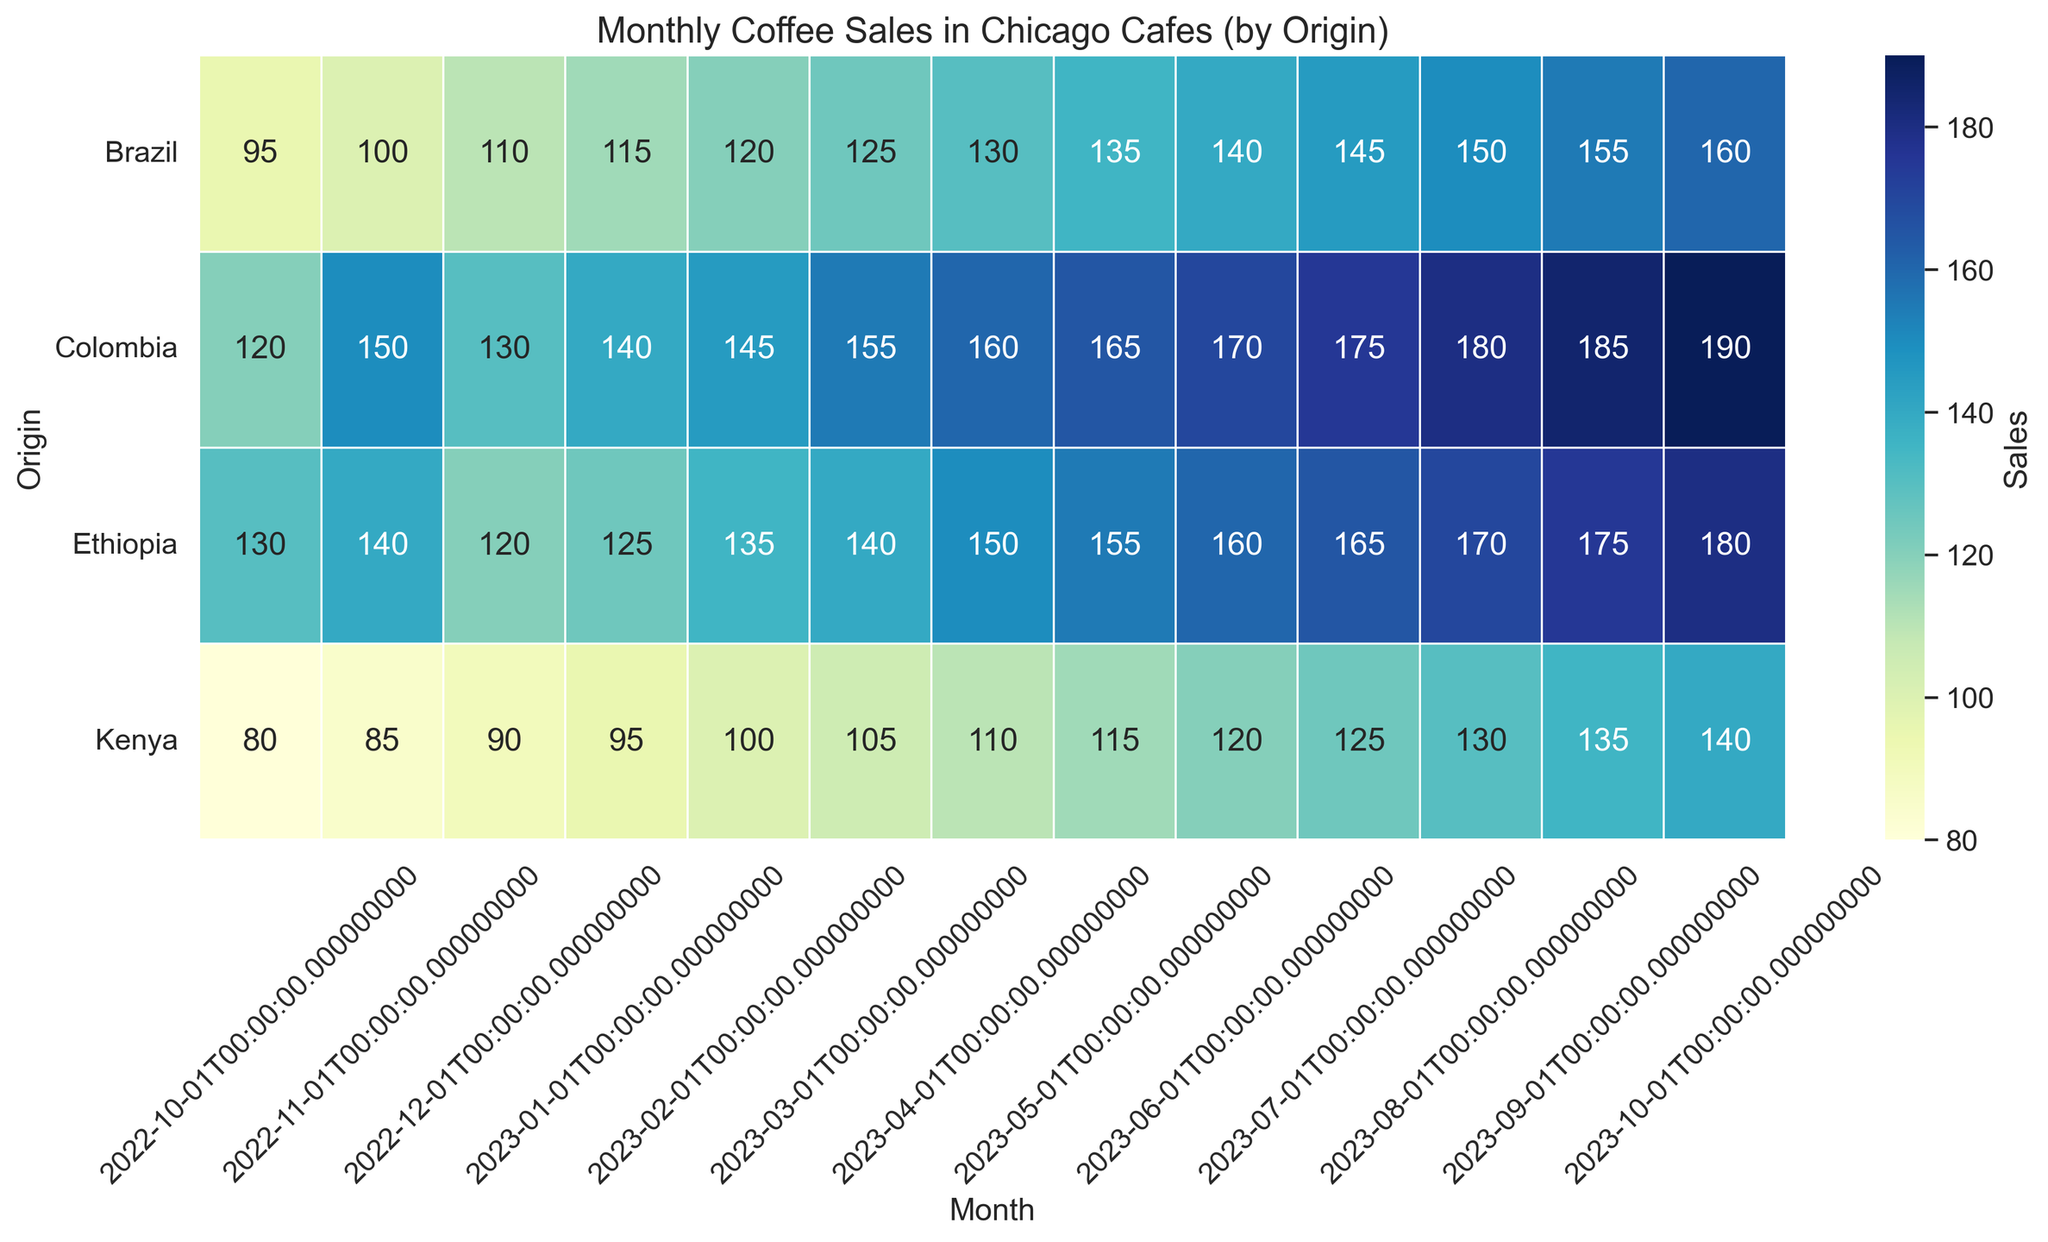Which month had the highest sales for Ethiopian coffee beans? To find this, observe the row corresponding to Ethiopia and identify the cell with the highest number.
Answer: October 2023 How did the sales of Kenyan coffee beans change from October 2022 to October 2023? Compare the October 2022 and October 2023 sales values for Kenyan coffee beans. Calculate the difference: 140 (2023) - 80 (2022) = 60.
Answer: Increased by 60 Which origin had the highest sales in December 2022? Look at the December 2022 column and identify the highest value among the origins.
Answer: Colombia What's the average monthly sales of Brazilian coffee beans from November 2022 to February 2023? Extract the sales figures for Brazil from November 2022 to February 2023, sum them up, and then divide by the number of months (4): (100 + 110 + 115 + 120)/4 = 111.25.
Answer: 111.25 Were Ethiopian coffee beans sales higher in March 2023 or in June 2023? Compare the sales figures for Ethiopia in March 2023 and June 2023: 140 (March) vs 160 (June).
Answer: June 2023 Compare the trend of sales for Colombian and Kenyan coffee beans from January 2023 to July 2023. Which origin had a steeper increase? Calculate the increase for both origins over the period: 
Colombian sales in July 2023 - January 2023 = 175 - 140 = 35. 
Kenyan sales in July 2023 - January 2023 = 125 - 95 = 30.
Answer: Colombia What is the total sales for all origins combined in April 2023? Sum the sales values for all origins in April 2023: 160 (Colombia) + 130 (Brazil) + 150 (Ethiopia) + 110 (Kenya) = 550.
Answer: 550 Which month/coffee origin combination had the lowest sales? Identify the cell with the lowest value in the heatmap.
Answer: Kenya in October 2022 Did the Brazilian coffee beans ever outsell Ethiopian coffee beans in any month's sales during this period? Compare monthly sales figures of Brazilian and Ethiopian coffee beans. Observe if any value for Brazil exceeds the corresponding value for Ethiopia.
Answer: No 